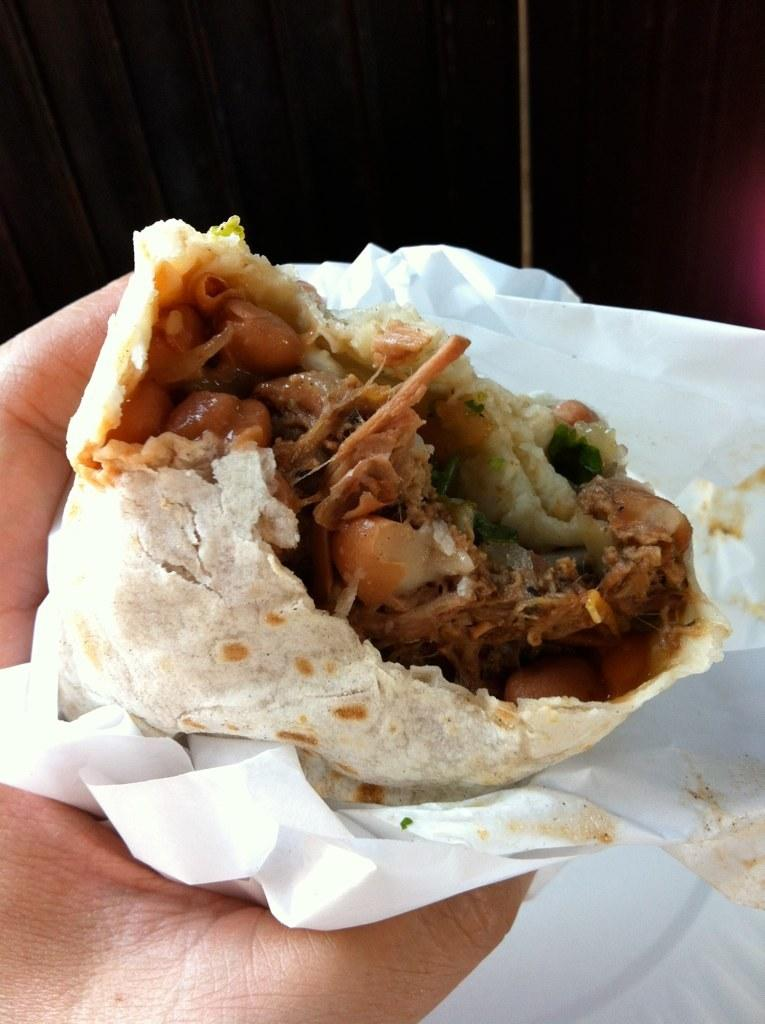What is the main subject of the image? There is a person in the image. What is the person holding in the image? The person is holding food. Can you identify any other objects in the image? Yes, there is a tissue paper in the image. Where is the deer in the image? There is no deer present in the image. What is the person starting in the image? The image does not depict the person starting anything; it simply shows them holding food. 